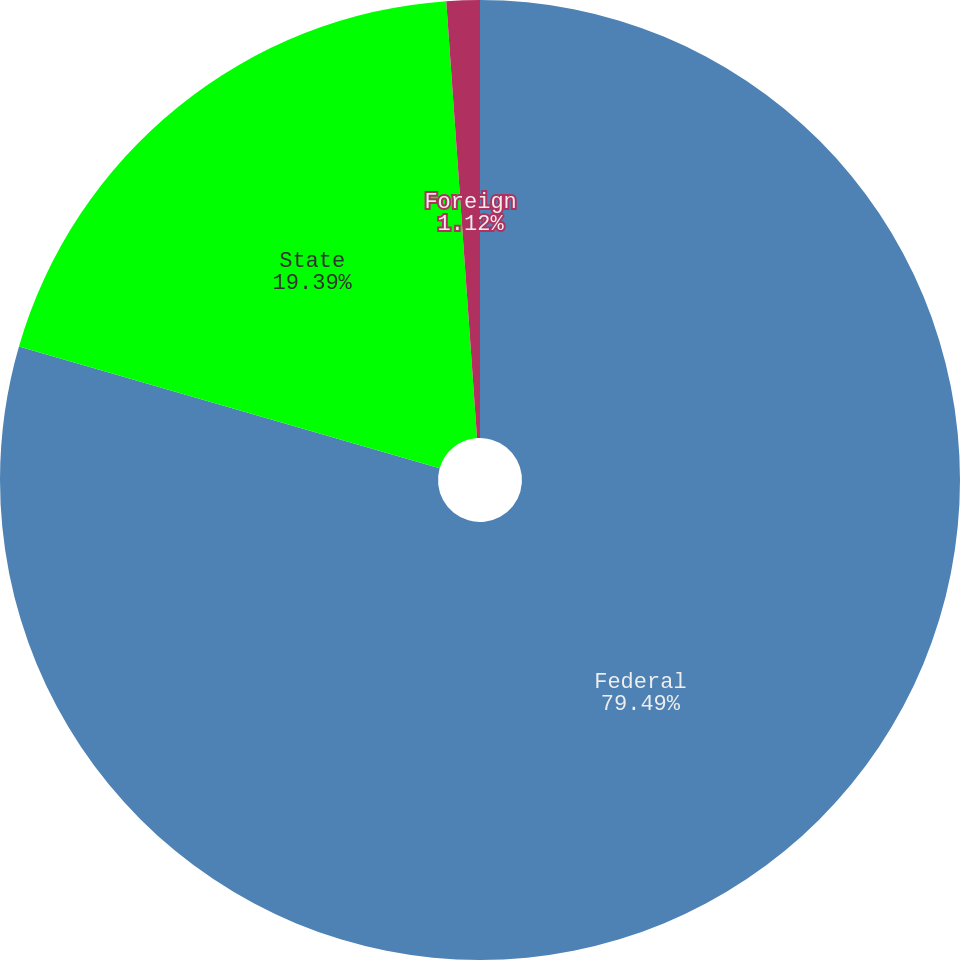Convert chart. <chart><loc_0><loc_0><loc_500><loc_500><pie_chart><fcel>Federal<fcel>State<fcel>Foreign<nl><fcel>79.48%<fcel>19.39%<fcel>1.12%<nl></chart> 